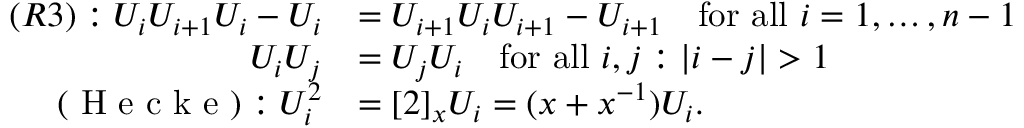Convert formula to latex. <formula><loc_0><loc_0><loc_500><loc_500>\begin{array} { r l } { ( R 3 ) \colon U _ { i } U _ { i + 1 } U _ { i } - U _ { i } } & { = U _ { i + 1 } U _ { i } U _ { i + 1 } - U _ { i + 1 } \quad f o r a l l i = 1 , \dots , n - 1 } \\ { U _ { i } U _ { j } } & { = U _ { j } U _ { i } \quad f o r a l l i , j \colon | i - j | > 1 } \\ { ( H e c k e ) \colon U _ { i } ^ { 2 } } & { = [ 2 ] _ { x } U _ { i } = ( x + x ^ { - 1 } ) U _ { i } . } \end{array}</formula> 